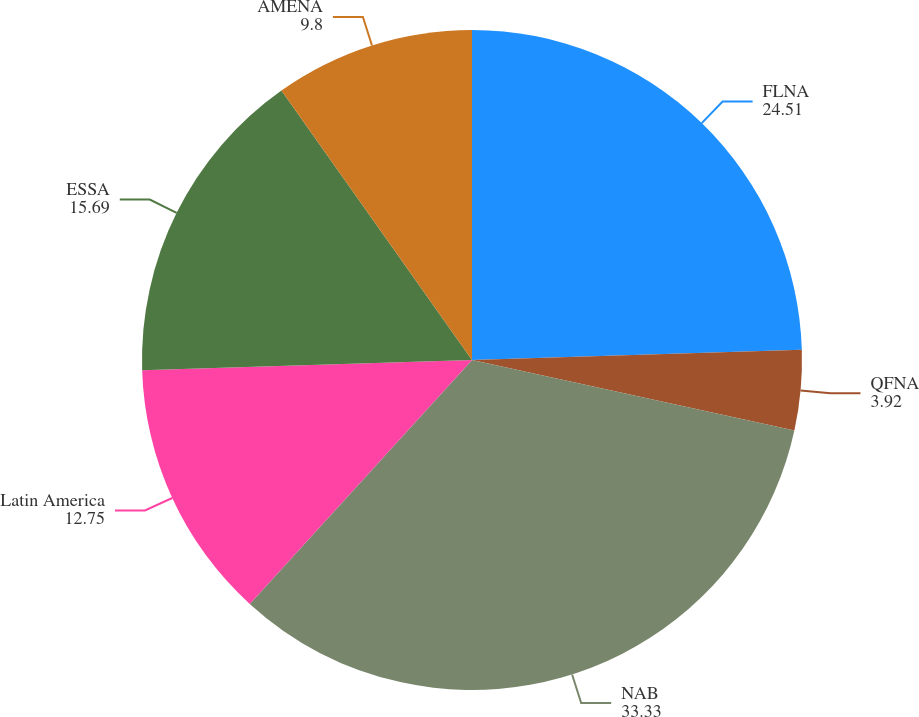Convert chart to OTSL. <chart><loc_0><loc_0><loc_500><loc_500><pie_chart><fcel>FLNA<fcel>QFNA<fcel>NAB<fcel>Latin America<fcel>ESSA<fcel>AMENA<nl><fcel>24.51%<fcel>3.92%<fcel>33.33%<fcel>12.75%<fcel>15.69%<fcel>9.8%<nl></chart> 